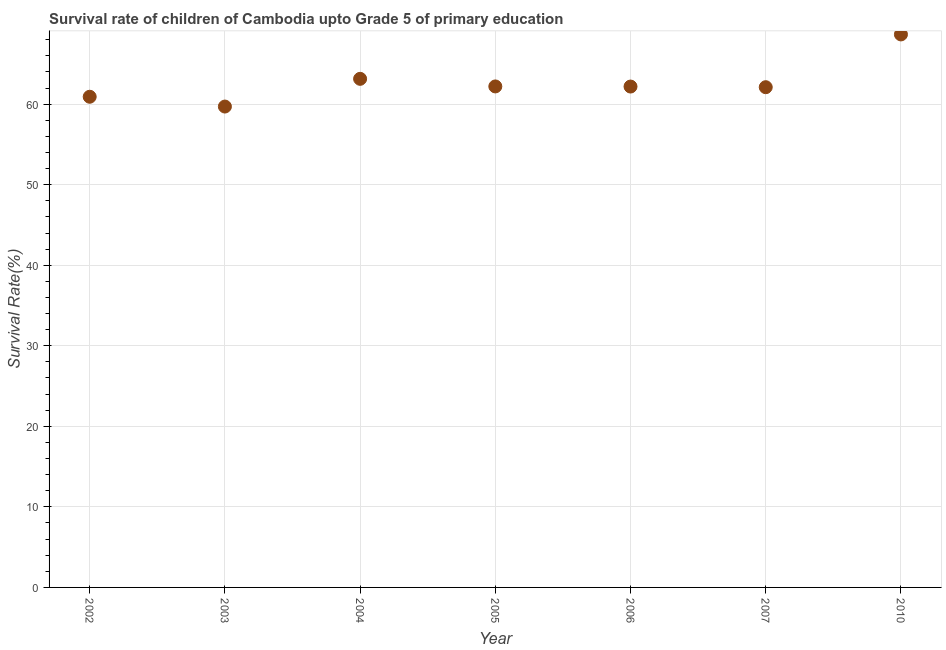What is the survival rate in 2007?
Ensure brevity in your answer.  62.1. Across all years, what is the maximum survival rate?
Offer a terse response. 68.65. Across all years, what is the minimum survival rate?
Provide a succinct answer. 59.7. What is the sum of the survival rate?
Provide a succinct answer. 438.89. What is the difference between the survival rate in 2006 and 2007?
Offer a very short reply. 0.08. What is the average survival rate per year?
Offer a very short reply. 62.7. What is the median survival rate?
Your answer should be compact. 62.18. Do a majority of the years between 2010 and 2005 (inclusive) have survival rate greater than 52 %?
Your response must be concise. Yes. What is the ratio of the survival rate in 2002 to that in 2003?
Your response must be concise. 1.02. Is the survival rate in 2005 less than that in 2007?
Ensure brevity in your answer.  No. Is the difference between the survival rate in 2003 and 2005 greater than the difference between any two years?
Offer a terse response. No. What is the difference between the highest and the second highest survival rate?
Ensure brevity in your answer.  5.51. What is the difference between the highest and the lowest survival rate?
Keep it short and to the point. 8.95. Does the survival rate monotonically increase over the years?
Make the answer very short. No. Are the values on the major ticks of Y-axis written in scientific E-notation?
Ensure brevity in your answer.  No. Does the graph contain any zero values?
Your response must be concise. No. Does the graph contain grids?
Your answer should be compact. Yes. What is the title of the graph?
Offer a very short reply. Survival rate of children of Cambodia upto Grade 5 of primary education. What is the label or title of the Y-axis?
Provide a short and direct response. Survival Rate(%). What is the Survival Rate(%) in 2002?
Give a very brief answer. 60.92. What is the Survival Rate(%) in 2003?
Provide a succinct answer. 59.7. What is the Survival Rate(%) in 2004?
Provide a succinct answer. 63.14. What is the Survival Rate(%) in 2005?
Ensure brevity in your answer.  62.2. What is the Survival Rate(%) in 2006?
Offer a very short reply. 62.18. What is the Survival Rate(%) in 2007?
Your response must be concise. 62.1. What is the Survival Rate(%) in 2010?
Offer a very short reply. 68.65. What is the difference between the Survival Rate(%) in 2002 and 2003?
Provide a succinct answer. 1.22. What is the difference between the Survival Rate(%) in 2002 and 2004?
Your answer should be compact. -2.22. What is the difference between the Survival Rate(%) in 2002 and 2005?
Ensure brevity in your answer.  -1.28. What is the difference between the Survival Rate(%) in 2002 and 2006?
Provide a short and direct response. -1.27. What is the difference between the Survival Rate(%) in 2002 and 2007?
Give a very brief answer. -1.19. What is the difference between the Survival Rate(%) in 2002 and 2010?
Provide a short and direct response. -7.74. What is the difference between the Survival Rate(%) in 2003 and 2004?
Keep it short and to the point. -3.44. What is the difference between the Survival Rate(%) in 2003 and 2005?
Offer a terse response. -2.5. What is the difference between the Survival Rate(%) in 2003 and 2006?
Your answer should be compact. -2.48. What is the difference between the Survival Rate(%) in 2003 and 2007?
Give a very brief answer. -2.4. What is the difference between the Survival Rate(%) in 2003 and 2010?
Provide a short and direct response. -8.95. What is the difference between the Survival Rate(%) in 2004 and 2005?
Your answer should be compact. 0.94. What is the difference between the Survival Rate(%) in 2004 and 2006?
Your answer should be compact. 0.96. What is the difference between the Survival Rate(%) in 2004 and 2007?
Give a very brief answer. 1.04. What is the difference between the Survival Rate(%) in 2004 and 2010?
Offer a terse response. -5.51. What is the difference between the Survival Rate(%) in 2005 and 2006?
Provide a succinct answer. 0.01. What is the difference between the Survival Rate(%) in 2005 and 2007?
Provide a short and direct response. 0.1. What is the difference between the Survival Rate(%) in 2005 and 2010?
Offer a very short reply. -6.46. What is the difference between the Survival Rate(%) in 2006 and 2007?
Keep it short and to the point. 0.08. What is the difference between the Survival Rate(%) in 2006 and 2010?
Ensure brevity in your answer.  -6.47. What is the difference between the Survival Rate(%) in 2007 and 2010?
Your response must be concise. -6.55. What is the ratio of the Survival Rate(%) in 2002 to that in 2005?
Ensure brevity in your answer.  0.98. What is the ratio of the Survival Rate(%) in 2002 to that in 2006?
Provide a succinct answer. 0.98. What is the ratio of the Survival Rate(%) in 2002 to that in 2007?
Your answer should be compact. 0.98. What is the ratio of the Survival Rate(%) in 2002 to that in 2010?
Your response must be concise. 0.89. What is the ratio of the Survival Rate(%) in 2003 to that in 2004?
Your answer should be very brief. 0.94. What is the ratio of the Survival Rate(%) in 2003 to that in 2006?
Give a very brief answer. 0.96. What is the ratio of the Survival Rate(%) in 2003 to that in 2010?
Keep it short and to the point. 0.87. What is the ratio of the Survival Rate(%) in 2004 to that in 2007?
Make the answer very short. 1.02. What is the ratio of the Survival Rate(%) in 2004 to that in 2010?
Your response must be concise. 0.92. What is the ratio of the Survival Rate(%) in 2005 to that in 2010?
Your answer should be very brief. 0.91. What is the ratio of the Survival Rate(%) in 2006 to that in 2007?
Offer a very short reply. 1. What is the ratio of the Survival Rate(%) in 2006 to that in 2010?
Your answer should be compact. 0.91. What is the ratio of the Survival Rate(%) in 2007 to that in 2010?
Keep it short and to the point. 0.91. 